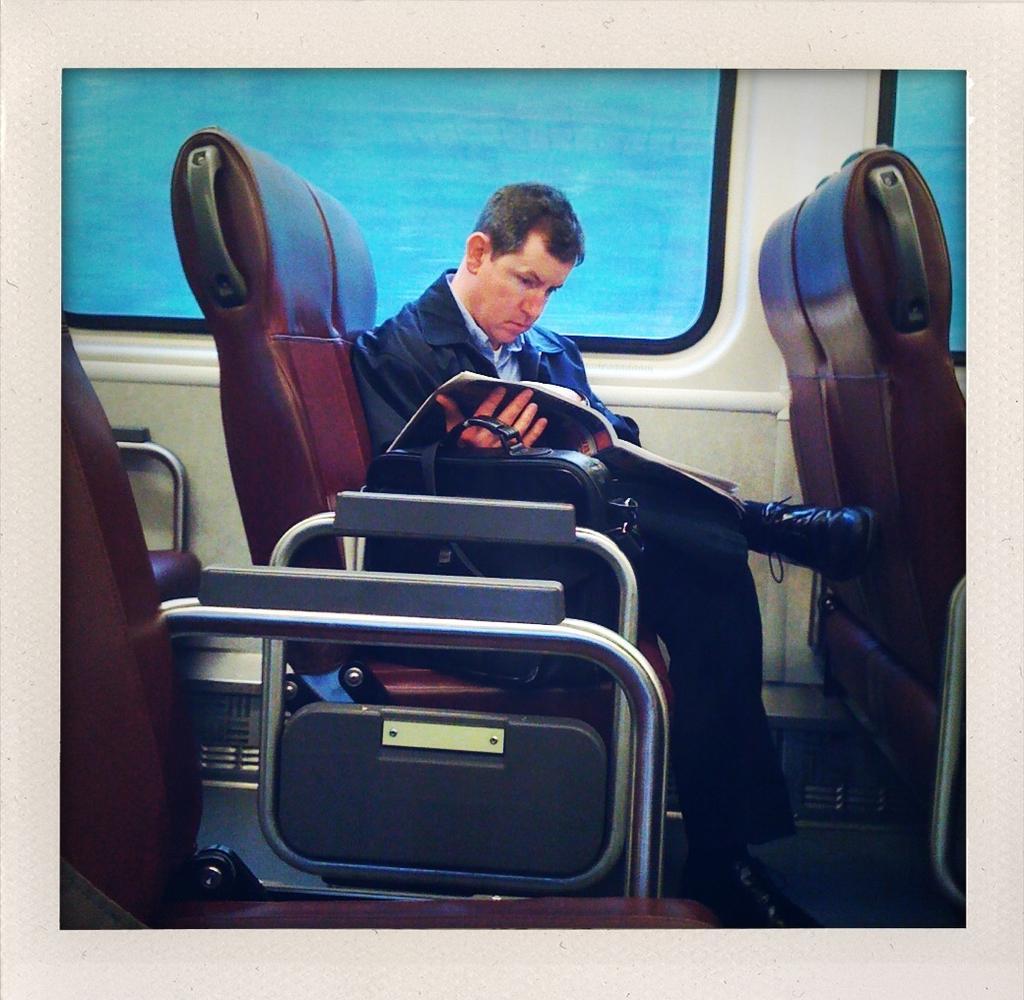Please provide a concise description of this image. In the center we can see one man sitting on the chair and holding book. Beside him we can see one bag,in the background there is a window and few chairs around him. 